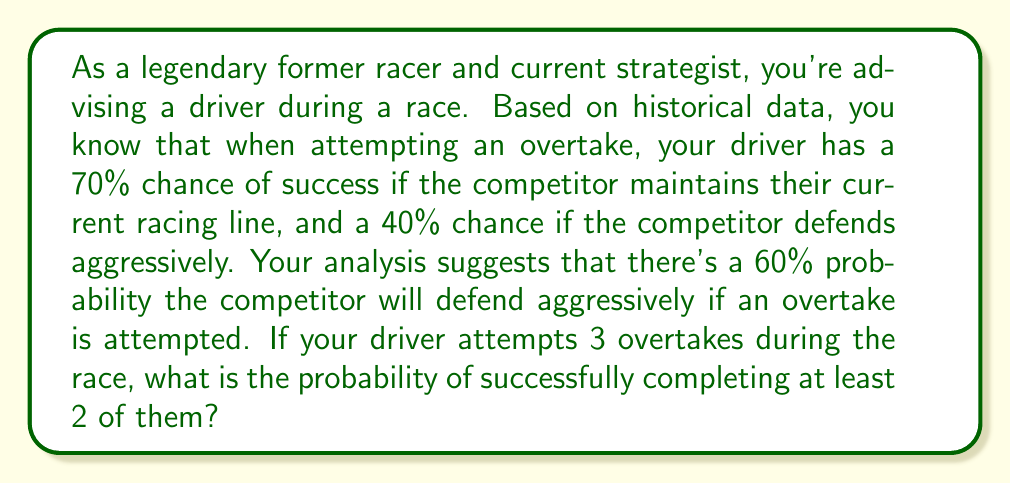Could you help me with this problem? Let's approach this step-by-step:

1) First, we need to calculate the overall probability of a successful overtake, considering both scenarios:

   P(success) = P(success|normal) * P(normal) + P(success|aggressive) * P(aggressive)
   $$ P(success) = 0.70 * 0.40 + 0.40 * 0.60 = 0.28 + 0.24 = 0.52 $$

2) Now, we have a situation where we're attempting 3 overtakes and want at least 2 successes. This follows a binomial probability distribution.

3) The probability of exactly 2 successes out of 3 attempts is:
   $$ P(X=2) = \binom{3}{2} * 0.52^2 * (1-0.52)^{3-2} $$
   $$ = 3 * 0.52^2 * 0.48 = 3 * 0.2704 * 0.48 = 0.3890 $$

4) The probability of exactly 3 successes out of 3 attempts is:
   $$ P(X=3) = \binom{3}{3} * 0.52^3 * (1-0.52)^{3-3} $$
   $$ = 1 * 0.52^3 * 1 = 0.1406 $$

5) The probability of at least 2 successes is the sum of the probabilities of 2 and 3 successes:
   $$ P(X \geq 2) = P(X=2) + P(X=3) = 0.3890 + 0.1406 = 0.5296 $$

Therefore, the probability of successfully completing at least 2 out of 3 overtake attempts is approximately 0.5296 or 52.96%.
Answer: 0.5296 